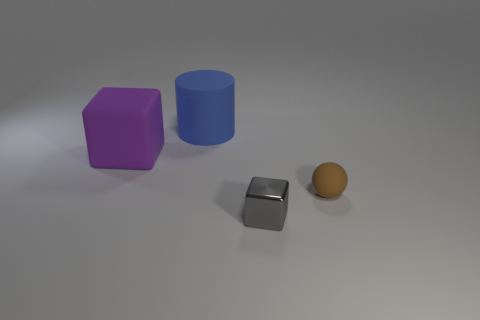Add 2 purple things. How many objects exist? 6 Subtract all purple cubes. How many cubes are left? 1 Subtract all spheres. How many objects are left? 3 Subtract 1 blocks. How many blocks are left? 1 Subtract all brown cubes. Subtract all brown spheres. How many cubes are left? 2 Subtract all blue cylinders. How many blue spheres are left? 0 Subtract all large blue cylinders. Subtract all gray things. How many objects are left? 2 Add 2 purple matte cubes. How many purple matte cubes are left? 3 Add 1 small gray metal cubes. How many small gray metal cubes exist? 2 Subtract 0 purple balls. How many objects are left? 4 